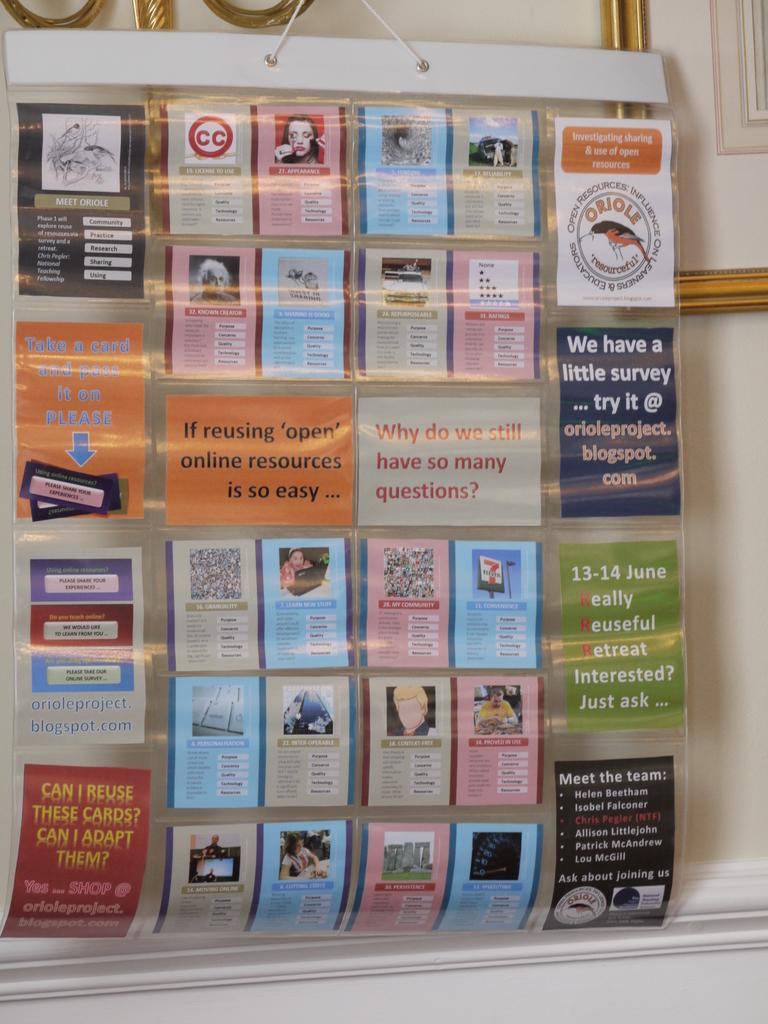Provide a one-sentence caption for the provided image. Cards and posters on a wall with one that says "Why do we still have so many questions?". 